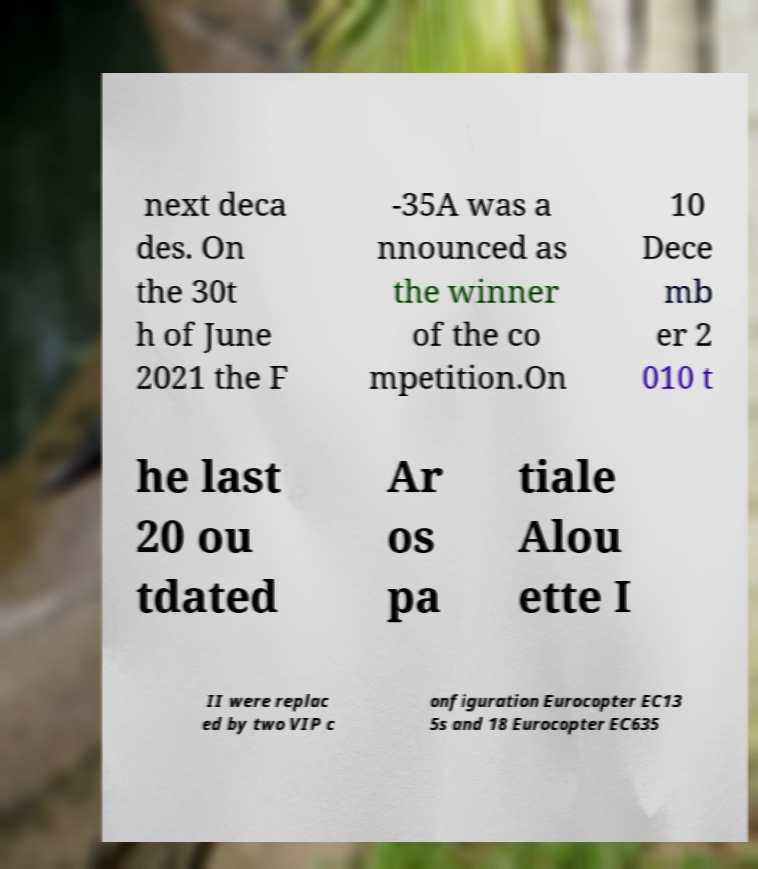Can you accurately transcribe the text from the provided image for me? next deca des. On the 30t h of June 2021 the F -35A was a nnounced as the winner of the co mpetition.On 10 Dece mb er 2 010 t he last 20 ou tdated Ar os pa tiale Alou ette I II were replac ed by two VIP c onfiguration Eurocopter EC13 5s and 18 Eurocopter EC635 